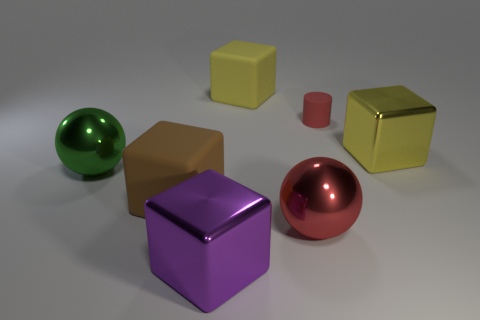What are the different colors of the objects in the image? The image features objects with various colors including green, brown, yellow, red, and purple. How many objects are there, and can you describe their shapes? There are five objects in total: a green sphere, a brown cube, a yellow cube, a red cylinder, and a purple cube. 